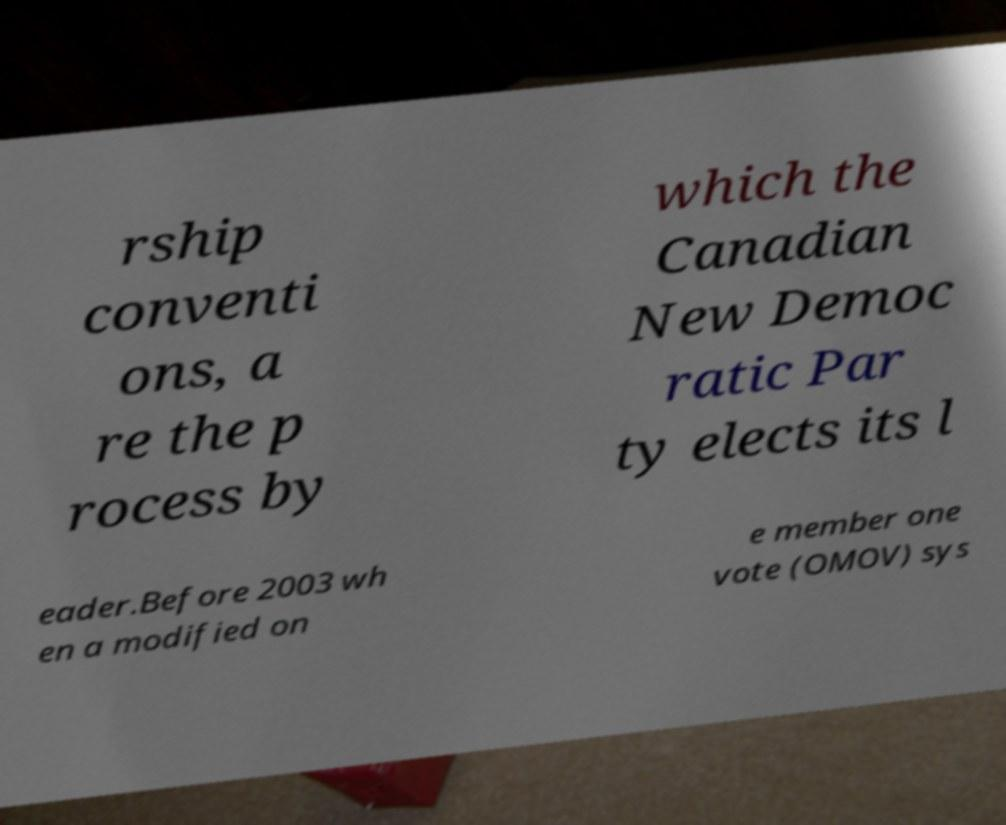For documentation purposes, I need the text within this image transcribed. Could you provide that? rship conventi ons, a re the p rocess by which the Canadian New Democ ratic Par ty elects its l eader.Before 2003 wh en a modified on e member one vote (OMOV) sys 